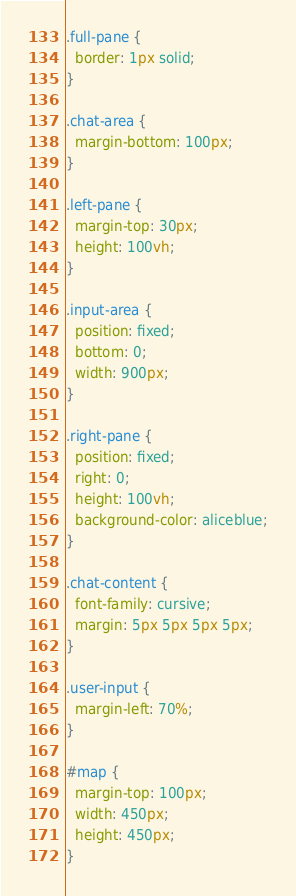Convert code to text. <code><loc_0><loc_0><loc_500><loc_500><_CSS_>.full-pane {
  border: 1px solid;
}

.chat-area {
  margin-bottom: 100px;
}

.left-pane {
  margin-top: 30px;
  height: 100vh;
}

.input-area {
  position: fixed;
  bottom: 0;
  width: 900px;
}

.right-pane {
  position: fixed;
  right: 0;
  height: 100vh;
  background-color: aliceblue;
}

.chat-content {
  font-family: cursive;
  margin: 5px 5px 5px 5px;
}

.user-input {
  margin-left: 70%;
}

#map {
  margin-top: 100px;
  width: 450px;
  height: 450px;
}</code> 